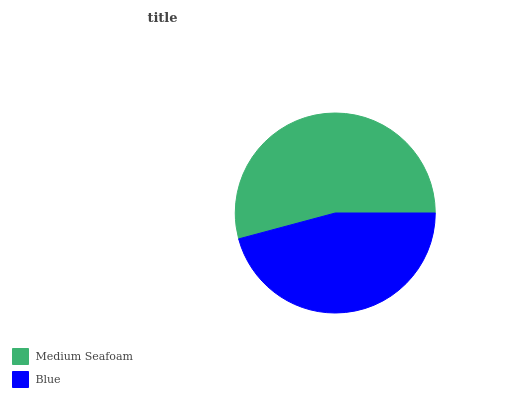Is Blue the minimum?
Answer yes or no. Yes. Is Medium Seafoam the maximum?
Answer yes or no. Yes. Is Blue the maximum?
Answer yes or no. No. Is Medium Seafoam greater than Blue?
Answer yes or no. Yes. Is Blue less than Medium Seafoam?
Answer yes or no. Yes. Is Blue greater than Medium Seafoam?
Answer yes or no. No. Is Medium Seafoam less than Blue?
Answer yes or no. No. Is Medium Seafoam the high median?
Answer yes or no. Yes. Is Blue the low median?
Answer yes or no. Yes. Is Blue the high median?
Answer yes or no. No. Is Medium Seafoam the low median?
Answer yes or no. No. 